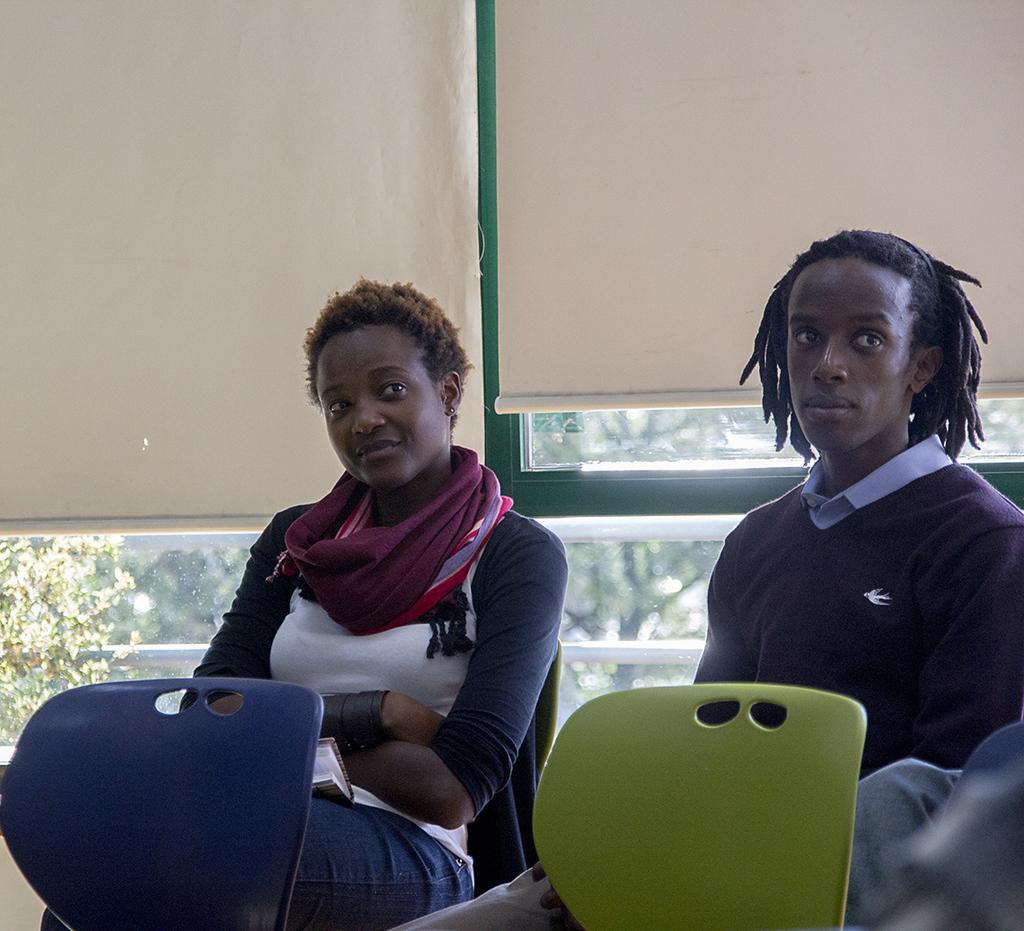Can you describe this image briefly? On the background we can see windows with curtains. Here we can see persons sitting on chairs. Through window glass we can see trees. In Front of the picture we can see two chairs in blue and green in colour. 